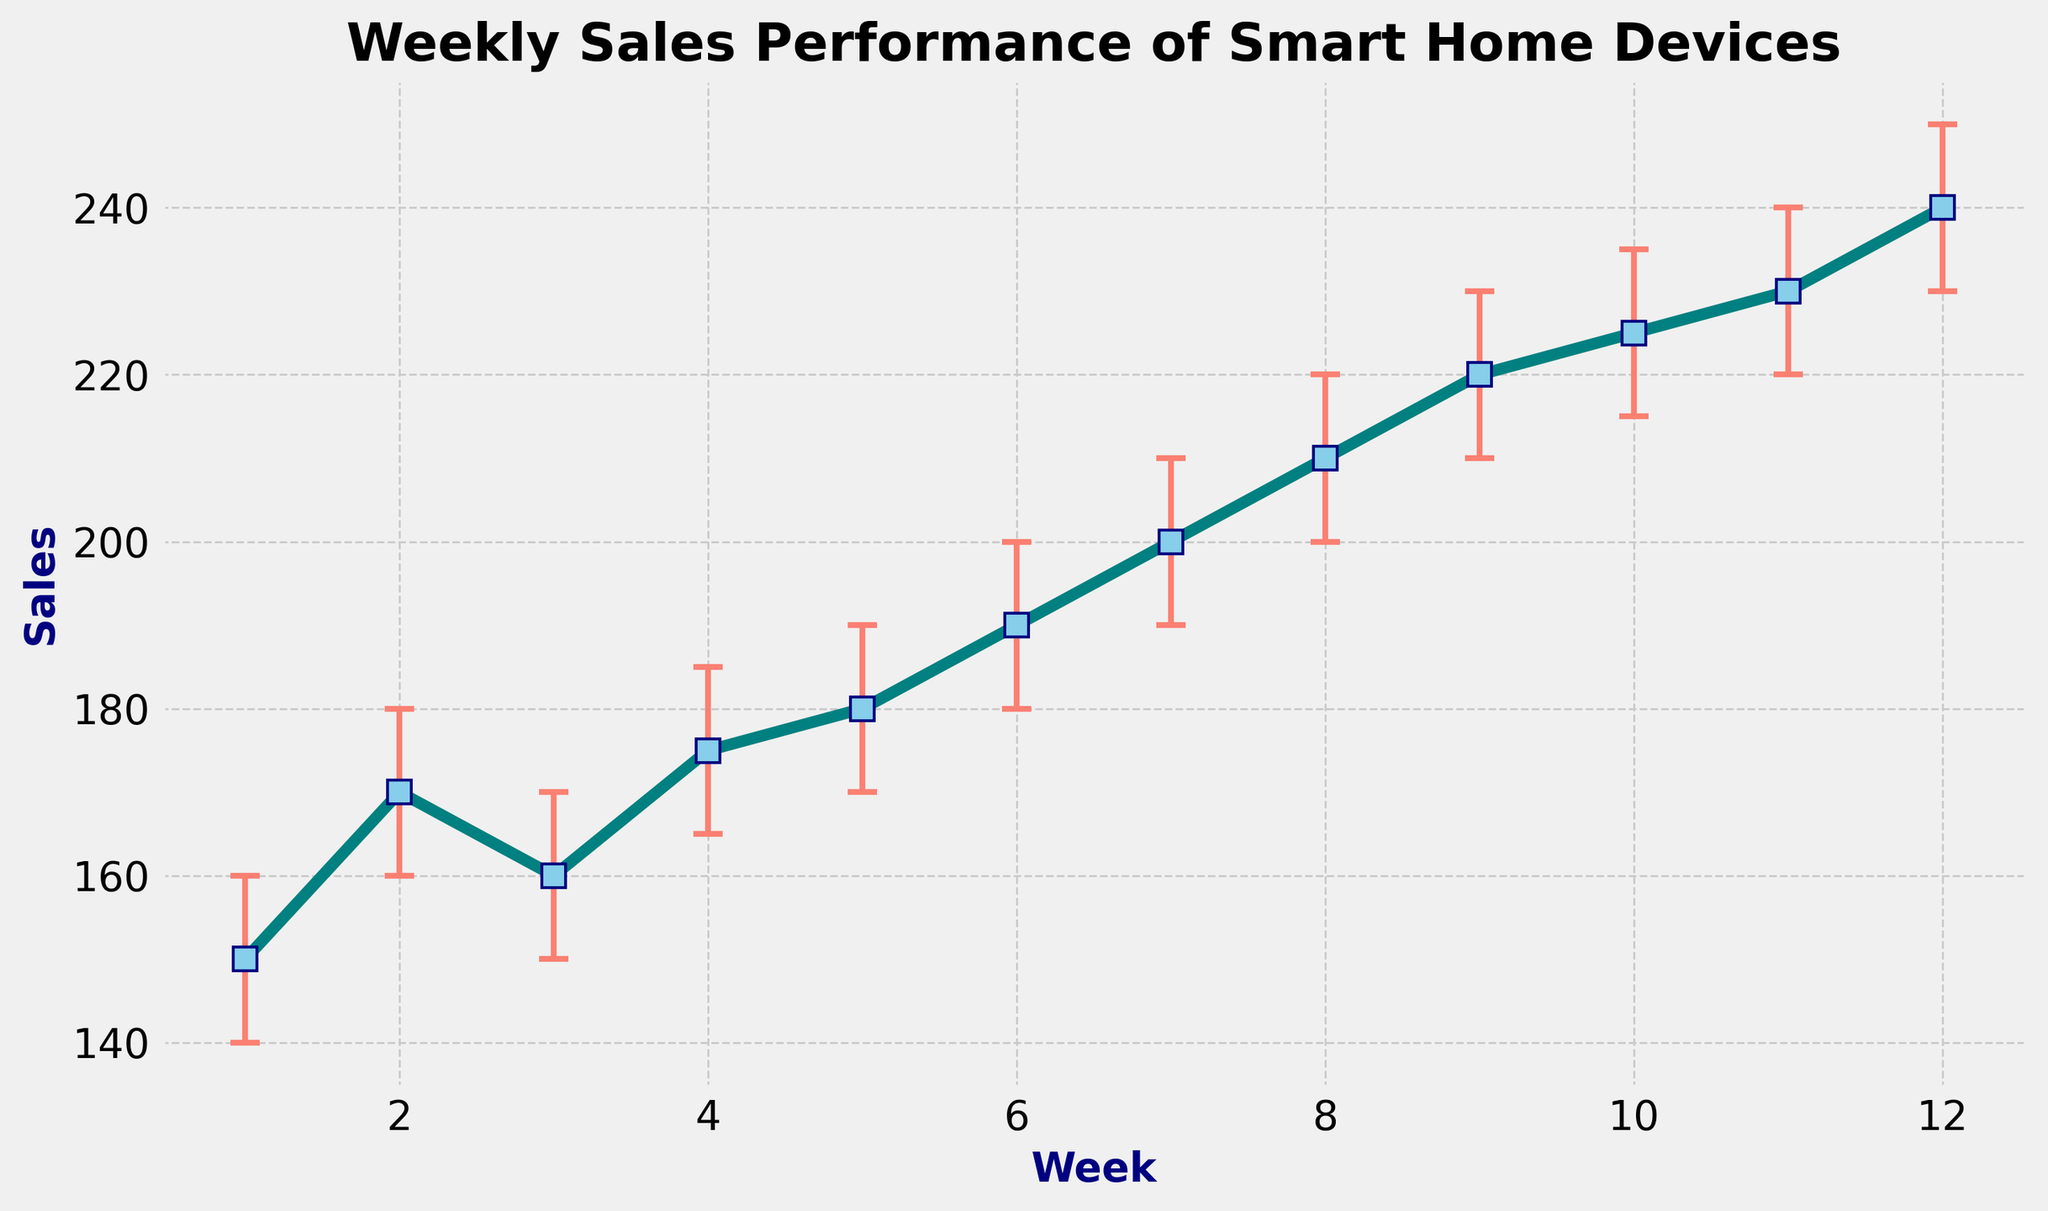What is the sales amount in the first week? Refer to the first data point in the chart, which marks the sales for Week 1. The exact sales amount is 150 units.
Answer: 150 Between which weeks did the sales experience the largest increase? Identify the intervals between weeks where the sales have increased the most by comparing the differences between consecutive points. The biggest increase occurs between Week 7 (200) and Week 8 (210).
Answer: Week 7 and Week 8 What is the average sales value over the 12 weeks? Sum up sales from all weeks: 150 + 170 + 160 + 175 + 180 + 190 + 200 + 210 + 220 + 225 + 230 + 240 = 2350. Divide by 12 for the average: 2350 / 12.
Answer: 195.83 In which week do the upper and lower confidence intervals show the greatest spread? Calculate the difference between UpperCI and LowerCI for each week and identify the week with the maximum spread. The maximum spread is 20, consistent across all weeks. So, any week can be chosen.
Answer: All weeks How do sales from Week 5 compare to Week 10? Refer to the sales values at Week 5 (180) and Week 10 (225). Sales in Week 10 are higher than in Week 5.
Answer: Week 10 is higher What color represents the error bars in the chart? Observe the color used for error bars. They are drawn in salmon color.
Answer: salmon What visual pattern do you observe in the sales trend over the 12 weeks? Notice the general shape of the plotted data points. The sales trend shows a gradual increasing pattern over the weeks.
Answer: Gradually increasing How much higher are the sales in Week 12 compared to Week 1? Subtract the sales value of Week 1 from Week 12: 240 - 150 = 90.
Answer: 90 What is the minimum weekly sales figure observed in the chart? Identify the lowest value among all plotted sales data points. The minimum weekly sales figure is 150, observed in Week 1.
Answer: 150 What is the range of sales values for Week 6, considering the confidence interval? The range is from the lower confidence interval to the upper confidence interval for Week 6. The values are from 180 to 200.
Answer: 180 to 200 